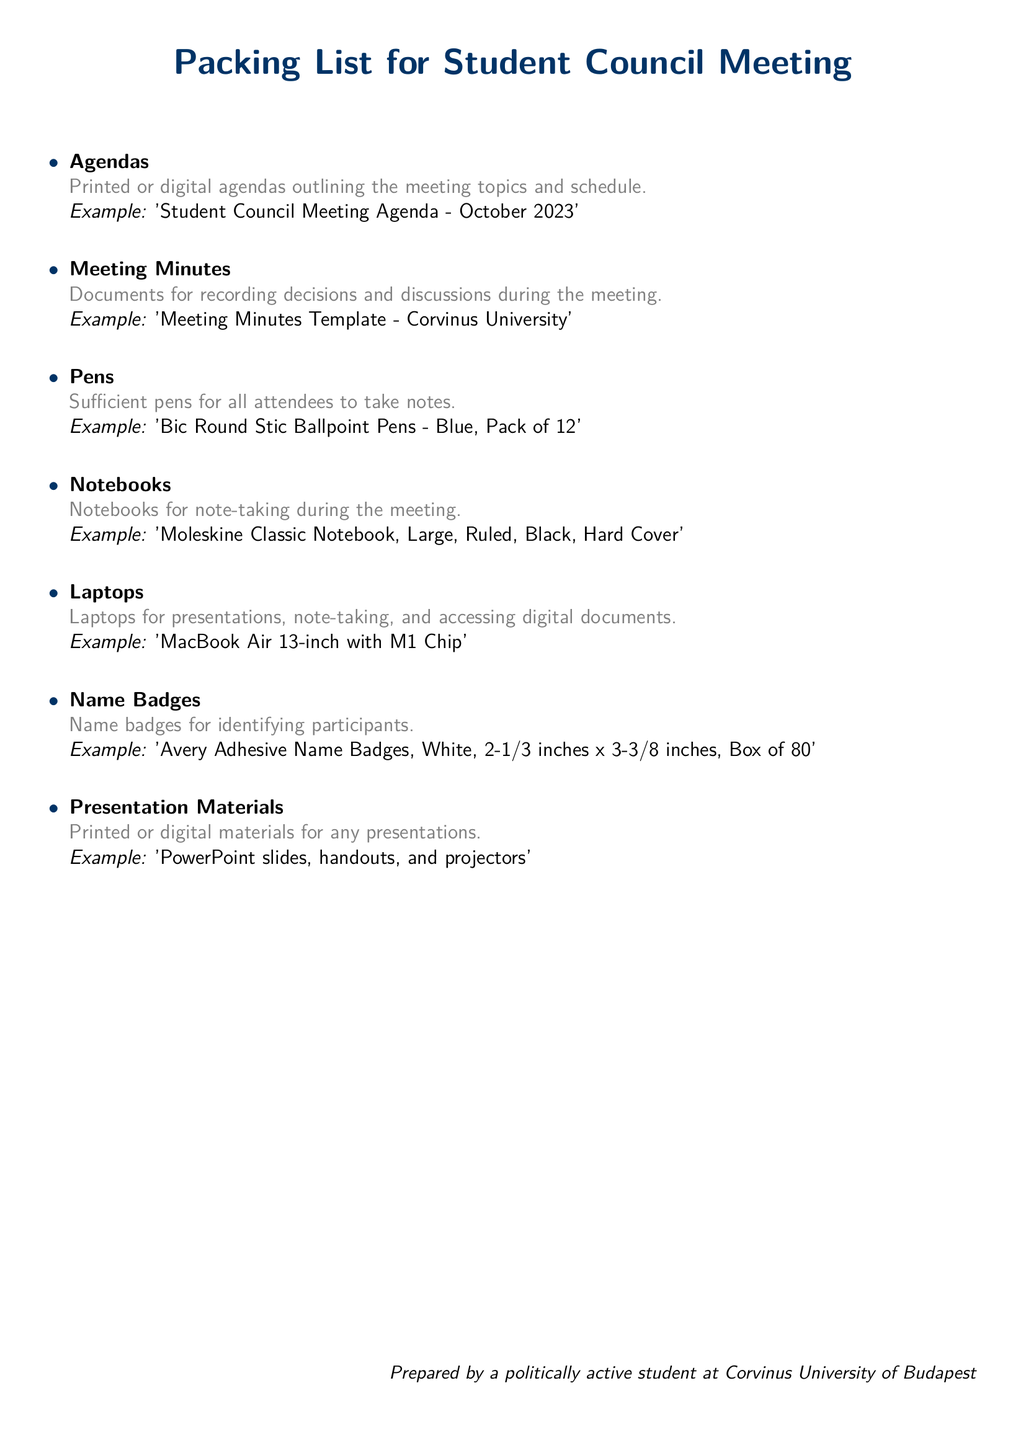What items are included in the packing list? The packing list includes specific items related to a Student Council Meeting such as agendas, meeting minutes, pens, notebooks, laptops, name badges, and presentation materials.
Answer: Agendas, meeting minutes, pens, notebooks, laptops, name badges, presentation materials What color are the example pens mentioned? The document specifies the color of the example pens as blue.
Answer: Blue How many name badges are in the example box? The detailed example for name badges indicates that there are 80 name badges in a box.
Answer: 80 What type of notebook is suggested in the packing list? The suggested notebook in the packing list is a Moleskine Classic Notebook.
Answer: Moleskine Classic Notebook What type of laptop is mentioned in the list? The packing list specifically mentions a MacBook Air with an M1 chip.
Answer: MacBook Air with M1 Chip Why are the name badges important? Name badges are important for identifying participants at the meeting.
Answer: Identifying participants What is the purpose of the meeting minutes? Meeting minutes are meant for recording decisions and discussions during the meeting.
Answer: Recording decisions and discussions How is the document prepared? The document is prepared by a politically active student at Corvinus University of Budapest.
Answer: Politically active student at Corvinus University of Budapest 